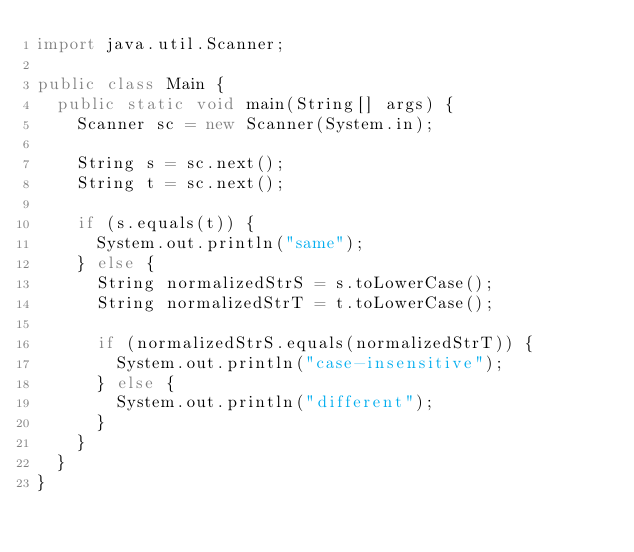<code> <loc_0><loc_0><loc_500><loc_500><_Java_>import java.util.Scanner;

public class Main {
  public static void main(String[] args) {
    Scanner sc = new Scanner(System.in);

    String s = sc.next();
    String t = sc.next();

    if (s.equals(t)) {
      System.out.println("same");
    } else {
      String normalizedStrS = s.toLowerCase();
      String normalizedStrT = t.toLowerCase();

      if (normalizedStrS.equals(normalizedStrT)) {
        System.out.println("case-insensitive");
      } else {
        System.out.println("different");
      }
    }
  }
}

</code> 